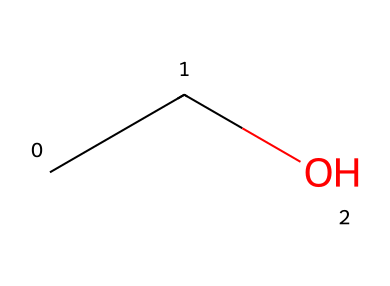What is the name of this chemical? The SMILES notation "CCO" corresponds to the structural formula of ethanol, which is a two-carbon alcohol.
Answer: ethanol How many carbon atoms are in this molecule? The SMILES representation indicates there are two carbon atoms, as each "C" in the notation represents one carbon.
Answer: 2 What type of chemical is represented by this structure? The presence of a hydroxyl group (-OH) in the structural formula indicates that it is an alcohol.
Answer: alcohol What is the total number of hydrogen atoms in this molecule? In the molecular formula for ethanol (C2H6O), there are six hydrogen atoms, which can be deduced from the carbon and oxygen counts.
Answer: 6 How many bonds are present between the carbon atoms? In the SMILES "CCO," the two carbon atoms are connected by a single bond, represented by the sequence of "C" symbols with no numbers indicating multiple bonds.
Answer: 1 What functional group is present in this compound? The hydroxyl group (-OH) attached to the carbon skeleton identifies ethanol as an alcohol, making it its defining functional group.
Answer: hydroxyl group 